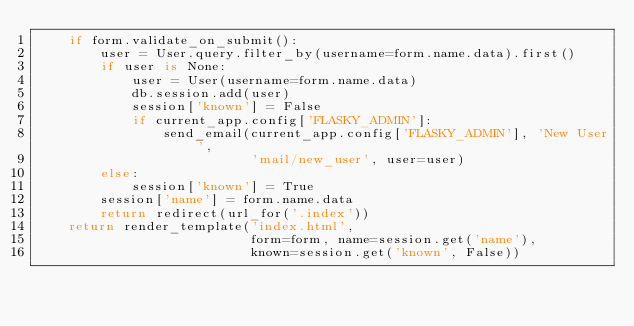Convert code to text. <code><loc_0><loc_0><loc_500><loc_500><_Python_>    if form.validate_on_submit():
        user = User.query.filter_by(username=form.name.data).first()
        if user is None:
            user = User(username=form.name.data)
            db.session.add(user)
            session['known'] = False
            if current_app.config['FLASKY_ADMIN']:
                send_email(current_app.config['FLASKY_ADMIN'], 'New User',
                           'mail/new_user', user=user)
        else:
            session['known'] = True
        session['name'] = form.name.data
        return redirect(url_for('.index'))
    return render_template('index.html',
                           form=form, name=session.get('name'),
                           known=session.get('known', False))
</code> 